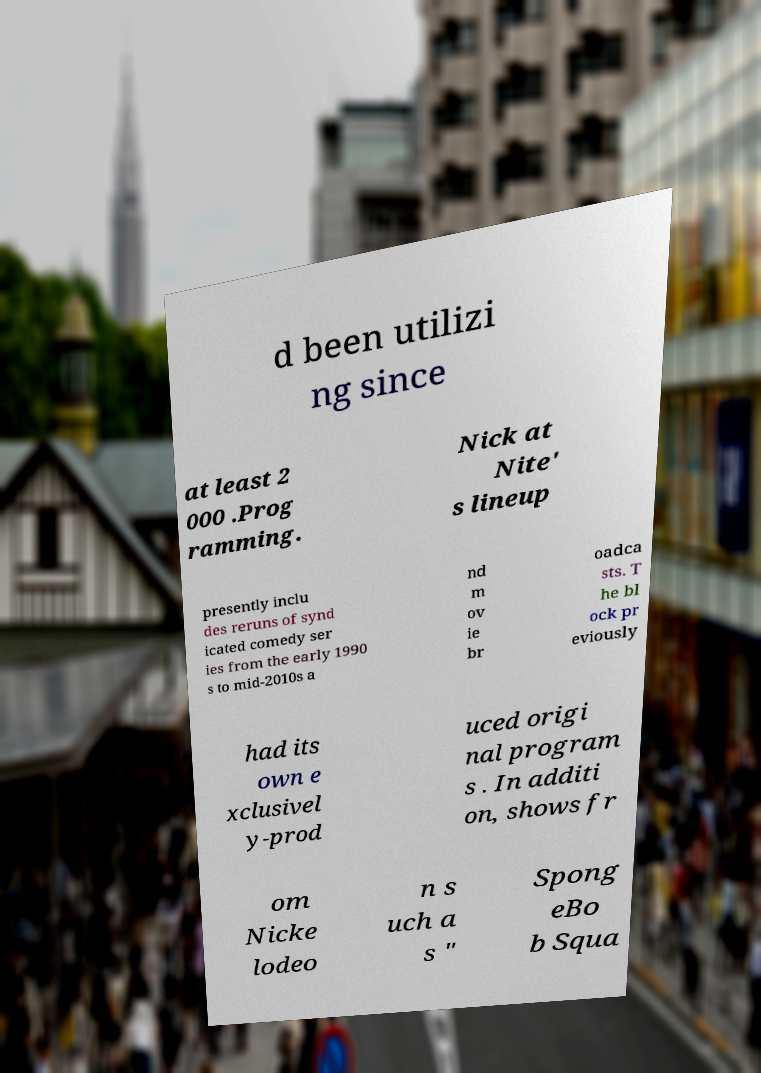Could you extract and type out the text from this image? d been utilizi ng since at least 2 000 .Prog ramming. Nick at Nite' s lineup presently inclu des reruns of synd icated comedy ser ies from the early 1990 s to mid-2010s a nd m ov ie br oadca sts. T he bl ock pr eviously had its own e xclusivel y-prod uced origi nal program s . In additi on, shows fr om Nicke lodeo n s uch a s " Spong eBo b Squa 